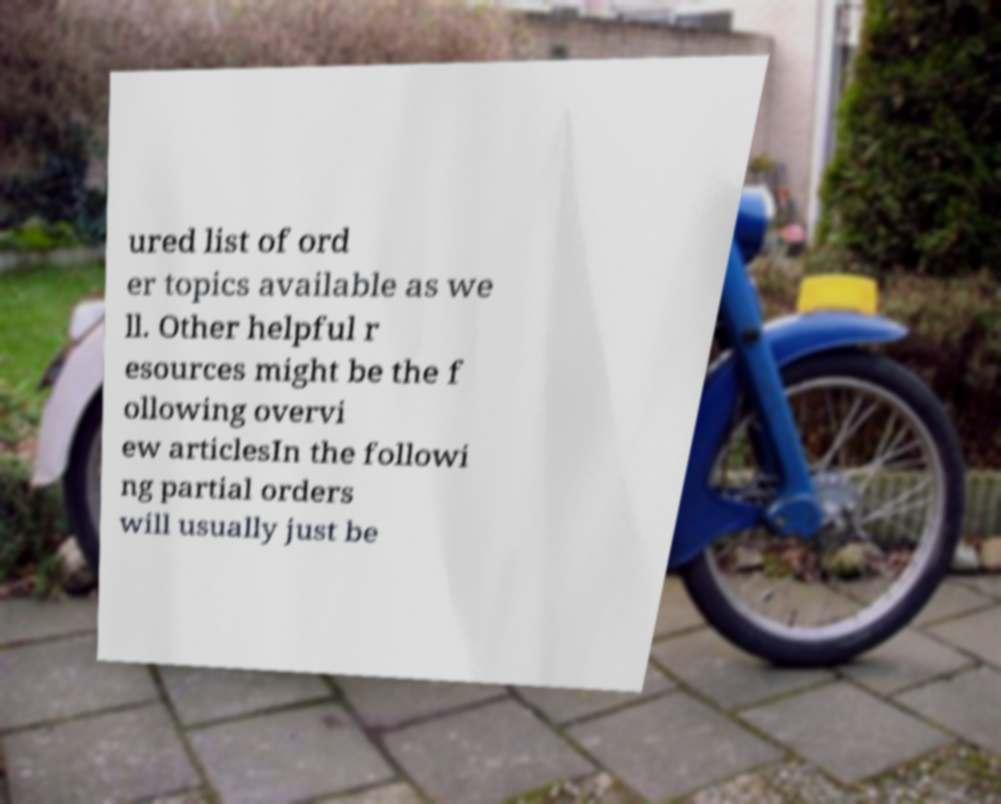I need the written content from this picture converted into text. Can you do that? ured list of ord er topics available as we ll. Other helpful r esources might be the f ollowing overvi ew articlesIn the followi ng partial orders will usually just be 